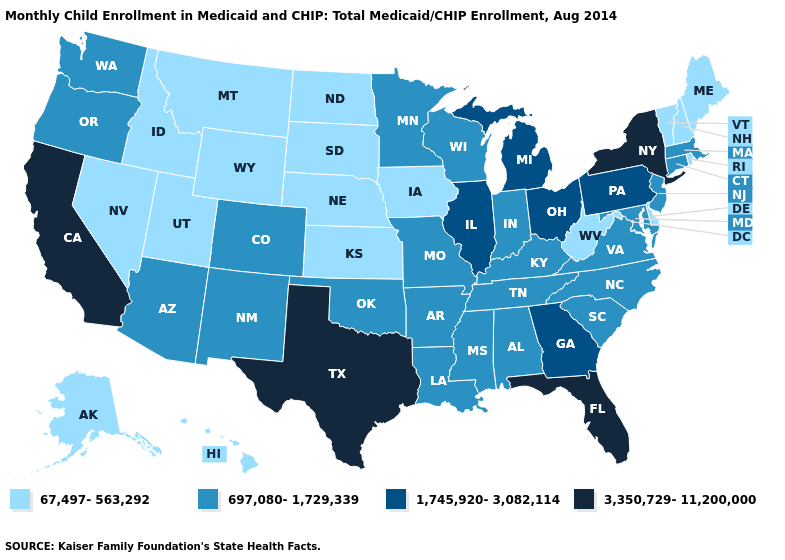Which states have the lowest value in the USA?
Give a very brief answer. Alaska, Delaware, Hawaii, Idaho, Iowa, Kansas, Maine, Montana, Nebraska, Nevada, New Hampshire, North Dakota, Rhode Island, South Dakota, Utah, Vermont, West Virginia, Wyoming. Which states hav the highest value in the West?
Quick response, please. California. Does the map have missing data?
Quick response, please. No. Does the first symbol in the legend represent the smallest category?
Give a very brief answer. Yes. Which states have the lowest value in the Northeast?
Keep it brief. Maine, New Hampshire, Rhode Island, Vermont. What is the value of Wyoming?
Concise answer only. 67,497-563,292. Among the states that border Tennessee , which have the highest value?
Answer briefly. Georgia. Name the states that have a value in the range 1,745,920-3,082,114?
Give a very brief answer. Georgia, Illinois, Michigan, Ohio, Pennsylvania. What is the value of Idaho?
Concise answer only. 67,497-563,292. Name the states that have a value in the range 3,350,729-11,200,000?
Quick response, please. California, Florida, New York, Texas. Does Iowa have the highest value in the MidWest?
Answer briefly. No. Does Minnesota have the same value as West Virginia?
Be succinct. No. Name the states that have a value in the range 3,350,729-11,200,000?
Write a very short answer. California, Florida, New York, Texas. What is the highest value in states that border Mississippi?
Keep it brief. 697,080-1,729,339. Name the states that have a value in the range 1,745,920-3,082,114?
Write a very short answer. Georgia, Illinois, Michigan, Ohio, Pennsylvania. 